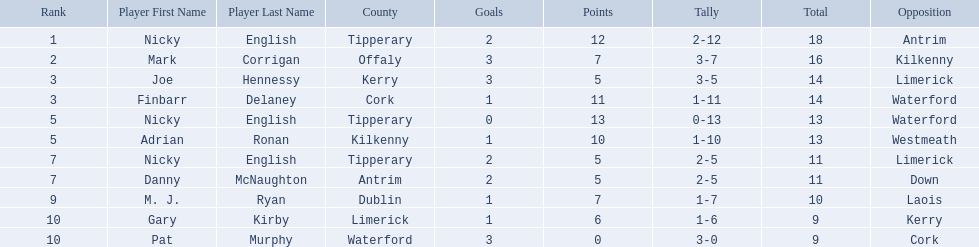Which of the following players were ranked in the bottom 5? Nicky English, Danny McNaughton, M. J. Ryan, Gary Kirby, Pat Murphy. Of these, whose tallies were not 2-5? M. J. Ryan, Gary Kirby, Pat Murphy. From the above three, which one scored more than 9 total points? M. J. Ryan. 